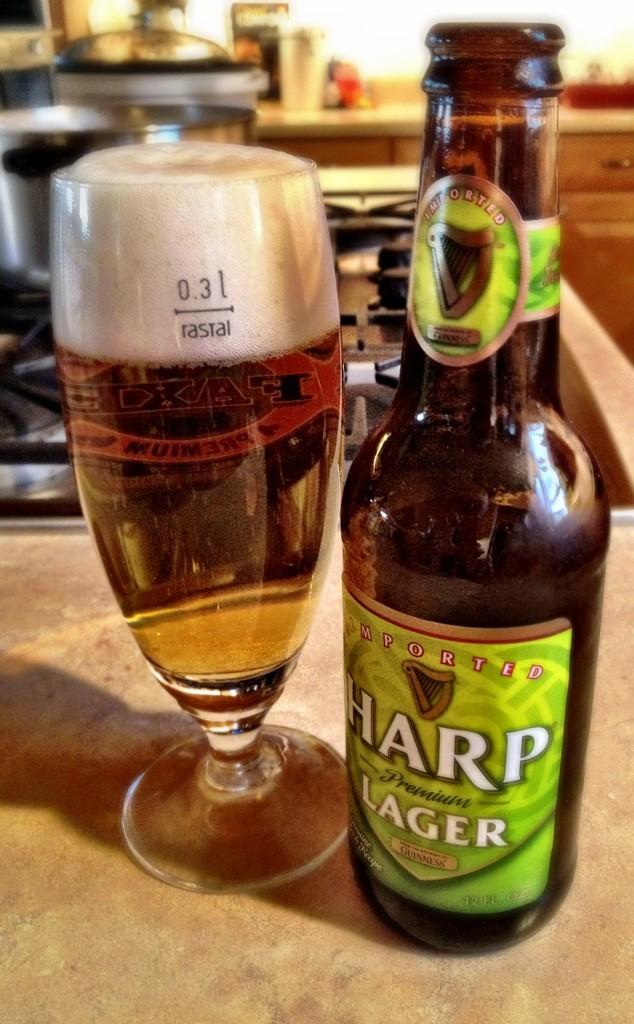<image>
Describe the image concisely. a bottle of harp lager standing next to a glass filled of it 